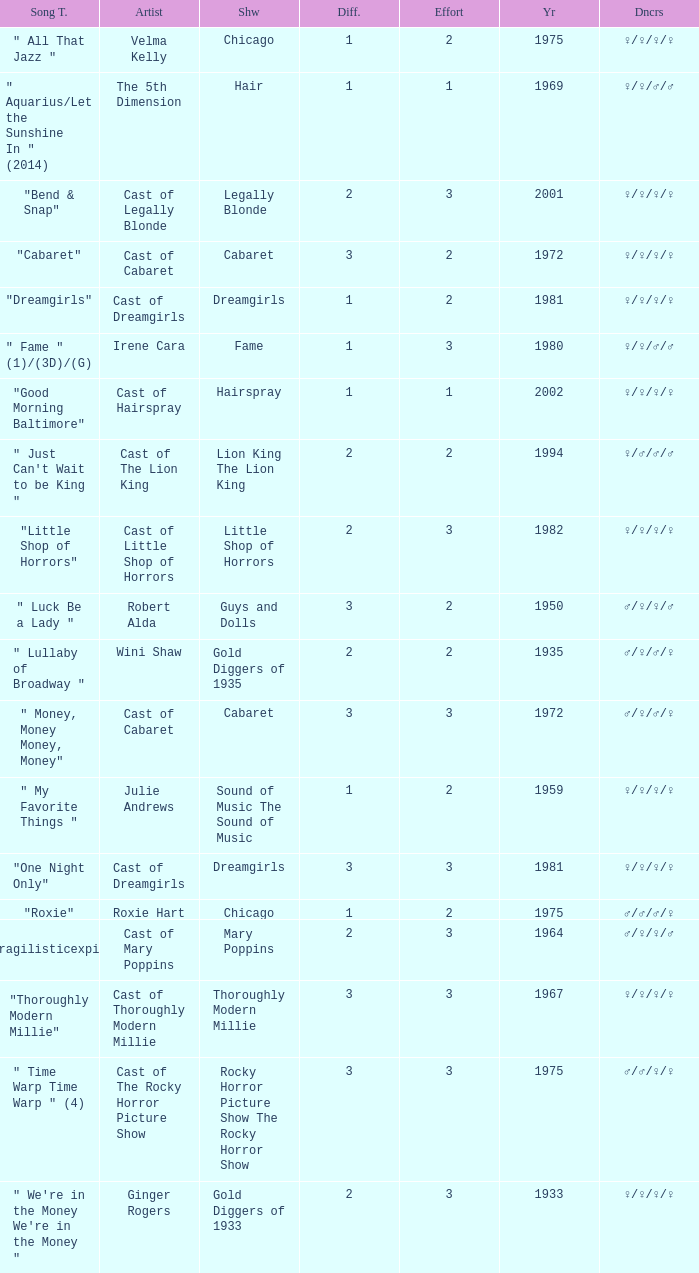How many shows were in 1994? 1.0. 